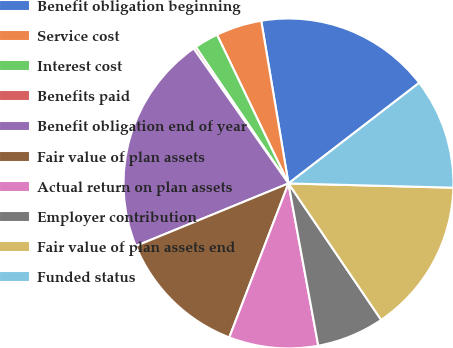Convert chart. <chart><loc_0><loc_0><loc_500><loc_500><pie_chart><fcel>Benefit obligation beginning<fcel>Service cost<fcel>Interest cost<fcel>Benefits paid<fcel>Benefit obligation end of year<fcel>Fair value of plan assets<fcel>Actual return on plan assets<fcel>Employer contribution<fcel>Fair value of plan assets end<fcel>Funded status<nl><fcel>17.2%<fcel>4.49%<fcel>2.37%<fcel>0.25%<fcel>21.44%<fcel>12.97%<fcel>8.73%<fcel>6.61%<fcel>15.09%<fcel>10.85%<nl></chart> 